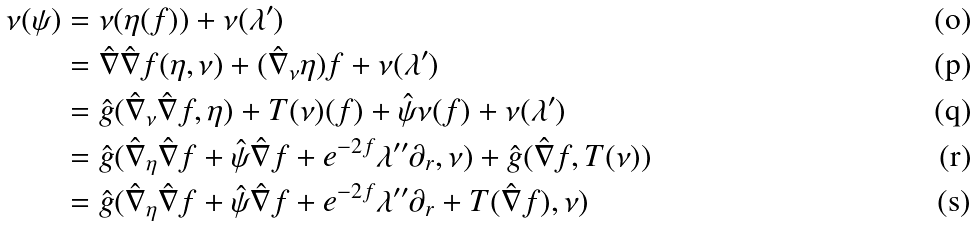<formula> <loc_0><loc_0><loc_500><loc_500>\nu ( \psi ) & = \nu ( \eta ( f ) ) + \nu ( \lambda ^ { \prime } ) \\ & = \hat { \nabla } \hat { \nabla } f ( \eta , \nu ) + ( \hat { \nabla } _ { \nu } \eta ) f + \nu ( \lambda ^ { \prime } ) \\ & = \hat { g } ( \hat { \nabla } _ { \nu } \hat { \nabla } f , \eta ) + T ( \nu ) ( f ) + \hat { \psi } \nu ( f ) + \nu ( \lambda ^ { \prime } ) \\ & = \hat { g } ( \hat { \nabla } _ { \eta } \hat { \nabla } f + \hat { \psi } \hat { \nabla } f + e ^ { - 2 f } \lambda ^ { \prime \prime } \partial _ { r } , \nu ) + \hat { g } ( \hat { \nabla } f , T ( \nu ) ) \\ & = \hat { g } ( \hat { \nabla } _ { \eta } \hat { \nabla } f + \hat { \psi } \hat { \nabla } f + e ^ { - 2 f } \lambda ^ { \prime \prime } \partial _ { r } + T ( \hat { \nabla } f ) , \nu )</formula> 